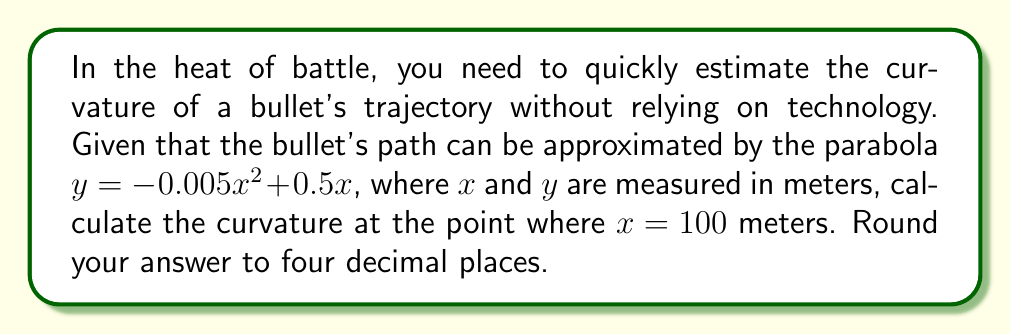Could you help me with this problem? Let's approach this step-by-step using our knowledge of differential geometry:

1) The general formula for curvature $K$ of a curve $y = f(x)$ at any point is:

   $$K = \frac{|f''(x)|}{(1 + [f'(x)]^2)^{3/2}}$$

2) First, we need to find $f'(x)$ and $f''(x)$:
   
   $f'(x) = -0.01x + 0.5$
   $f''(x) = -0.01$

3) At $x = 100$:
   
   $f'(100) = -0.01(100) + 0.5 = -0.5$
   $f''(100) = -0.01$

4) Now, let's substitute these values into our curvature formula:

   $$K = \frac{|-0.01|}{(1 + [-0.5]^2)^{3/2}}$$

5) Simplify:
   
   $$K = \frac{0.01}{(1 + 0.25)^{3/2}} = \frac{0.01}{(1.25)^{3/2}}$$

6) Calculate:
   
   $$K \approx 0.0071492$$

7) Rounding to four decimal places:
   
   $$K \approx 0.0071$$
Answer: 0.0071 